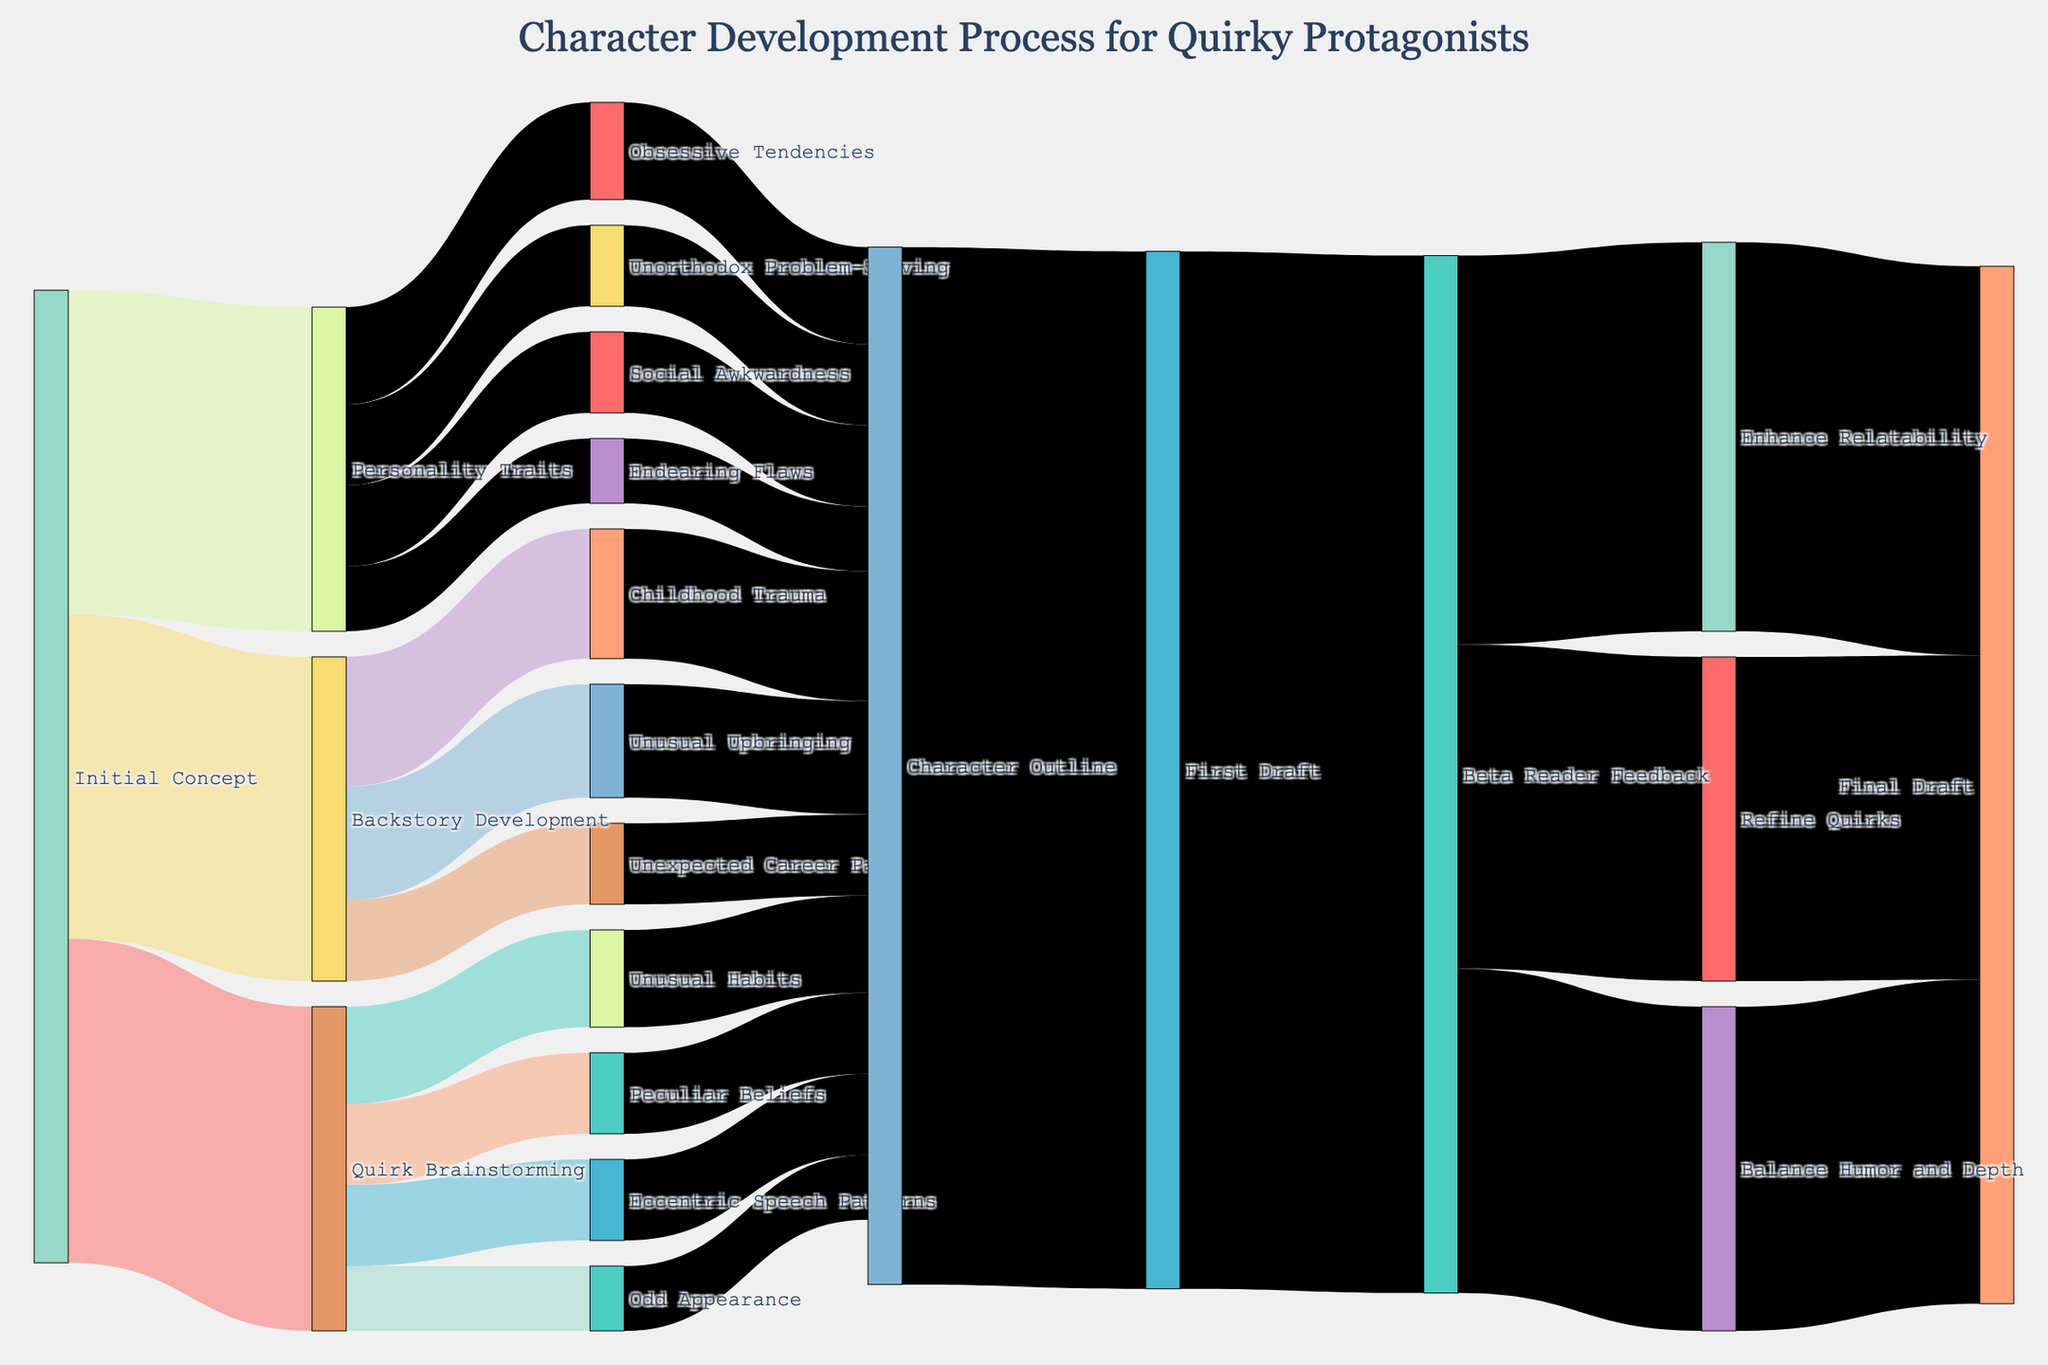What's the title of the Sankey diagram? The title of a plot is usually placed at the top. In this case, the title is "Character Development Process for Quirky Protagonists," as observed from the layout.
Answer: Character Development Process for Quirky Protagonists How many total steps are there from "Initial Concept" to "First Draft"? By tracing the flow from "Initial Concept" through each subsequent node to "First Draft," we can see the steps involved: "Initial Concept", "Quirk Brainstorming", "Backstory Development", "Personality Traits", and finally "Character Outline". This sums up to a total of 5 steps.
Answer: 5 Which stage has the highest number of subdivisions directly from "Initial Concept"? To find this, we can count the direct subdivisions from "Initial Concept": "Quirk Brainstorming" (4), "Backstory Development" (3), and "Personality Traits" (4). Both "Quirk Brainstorming" and "Personality Traits" have the highest number, which is 4 each.
Answer: Quirk Brainstorming and Personality Traits What is the total value that flows into "Character Outline"? To find the total value flowing into "Character Outline," add all the connections leading to it: 30 (Unusual Habits) + 25 (Eccentric Speech Patterns) + 25 (Peculiar Beliefs) + 20 (Odd Appearance) + 40 (Childhood Trauma) + 35 (Unusual Upbringing) + 25 (Unexpected Career Path) + 30 (Obsessive Tendencies) + 25 (Social Awkwardness) + 25 (Unorthodox Problem-Solving) + 20 (Endearing Flaws) = 320.
Answer: 320 How does the value from "Beta Reader Feedback" distribute into different refinement areas? From "Beta Reader Feedback," the total value of 320 is distributed into "Refine Quirks" (100), "Enhance Relatability" (120), and "Balance Humor and Depth" (100). The distribution shows different areas where the focus lies for refinement.
Answer: Refine Quirks (100), Enhance Relatability (120), Balance Humor and Depth (100) Which refinement area receives the most attention from "Beta Reader Feedback"? To determine this, compare the values of each refinement area: "Refine Quirks" (100), "Enhance Relatability" (120), and "Balance Humor and Depth" (100). "Enhance Relatability" receives the most attention with 120.
Answer: Enhance Relatability What is the final total value at the "Final Draft" stage? By adding up all the values that lead to "Final Draft": "Refine Quirks" (100) + "Enhance Relatability" (120) + "Balance Humor and Depth" (100) = 320. This is the final total value at the "Final Draft" stage.
Answer: 320 